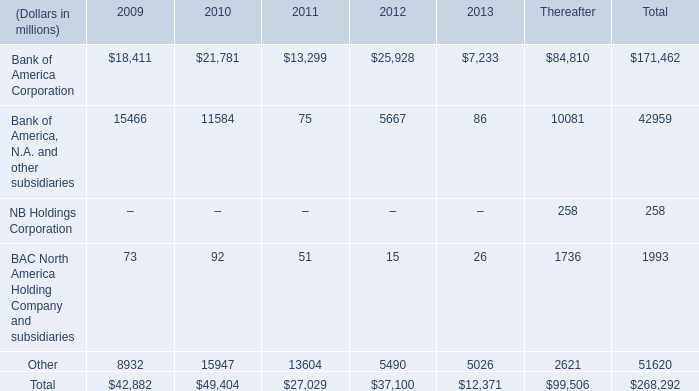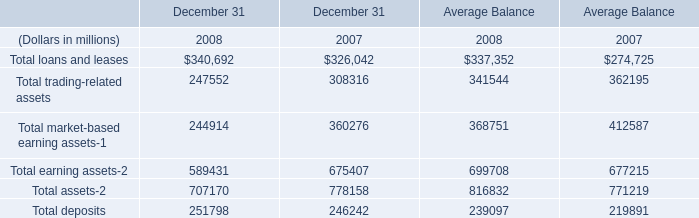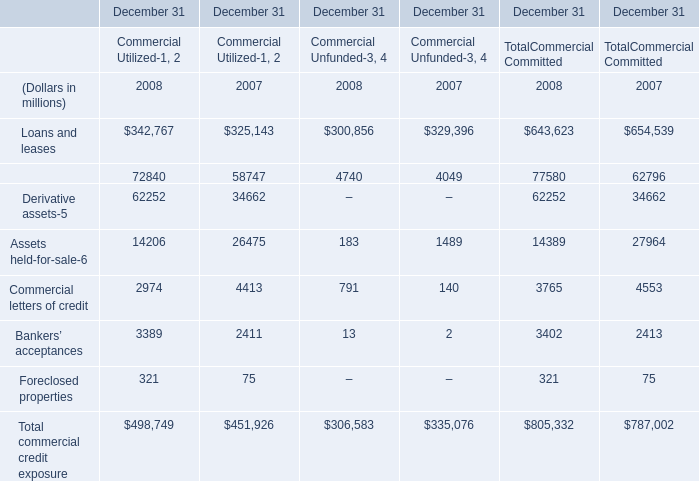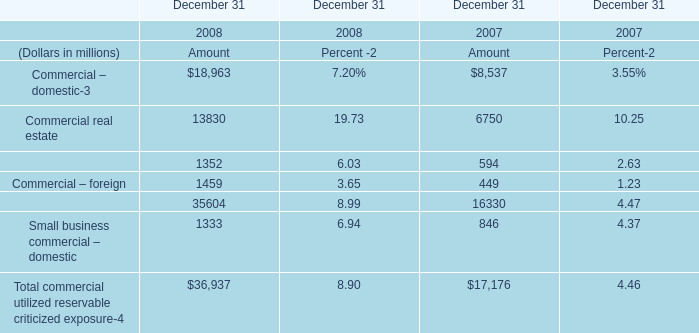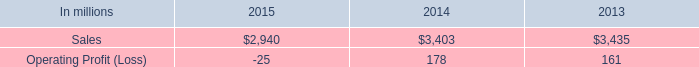What's the average of Commercial real estate and Commercial lease financing for Amount in 2008? (in dollars in millions) 
Computations: ((13830 + 1352) / 2)
Answer: 7591.0. 